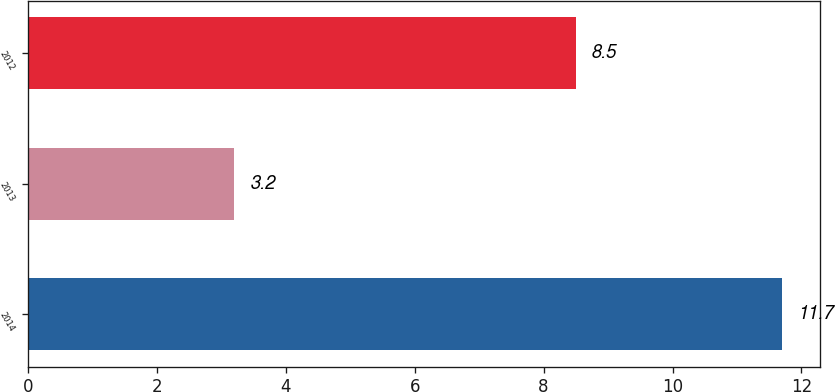Convert chart. <chart><loc_0><loc_0><loc_500><loc_500><bar_chart><fcel>2014<fcel>2013<fcel>2012<nl><fcel>11.7<fcel>3.2<fcel>8.5<nl></chart> 